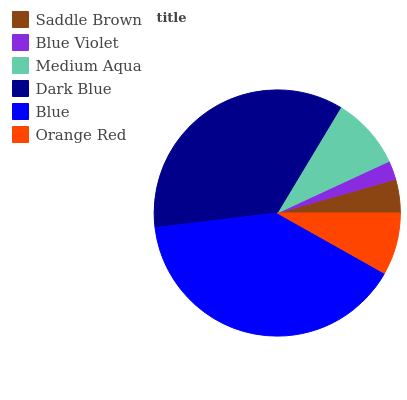Is Blue Violet the minimum?
Answer yes or no. Yes. Is Blue the maximum?
Answer yes or no. Yes. Is Medium Aqua the minimum?
Answer yes or no. No. Is Medium Aqua the maximum?
Answer yes or no. No. Is Medium Aqua greater than Blue Violet?
Answer yes or no. Yes. Is Blue Violet less than Medium Aqua?
Answer yes or no. Yes. Is Blue Violet greater than Medium Aqua?
Answer yes or no. No. Is Medium Aqua less than Blue Violet?
Answer yes or no. No. Is Medium Aqua the high median?
Answer yes or no. Yes. Is Orange Red the low median?
Answer yes or no. Yes. Is Saddle Brown the high median?
Answer yes or no. No. Is Dark Blue the low median?
Answer yes or no. No. 